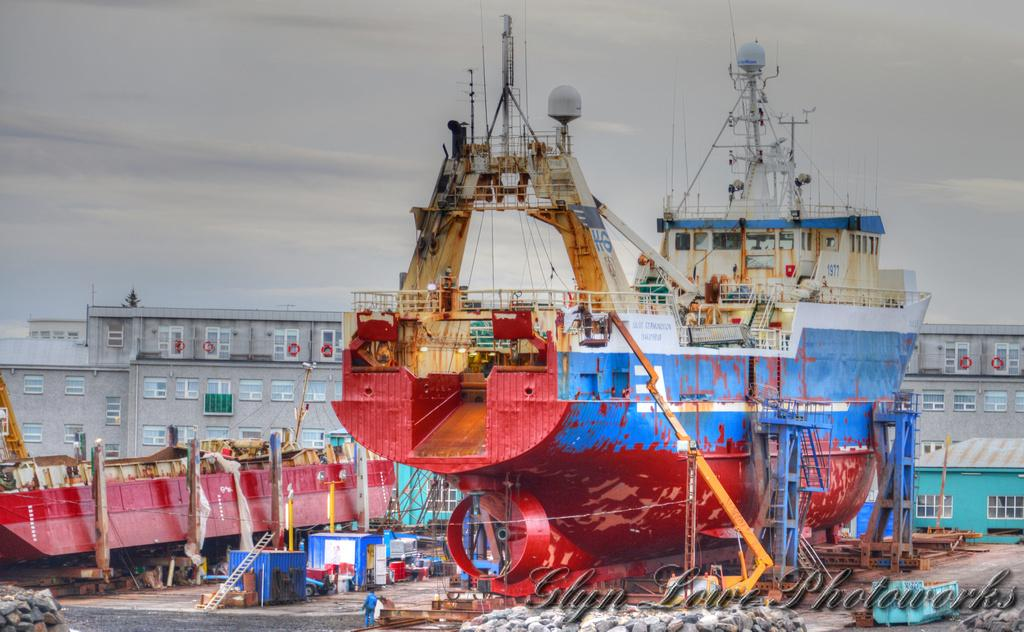What types of structures can be seen in the foreground of the image? There are buildings in the foreground of the image. What is another large object visible in the foreground? There is a ship in the foreground of the image. What natural elements are present in the foreground? There are rocks in the foreground of the image. Are there any living beings in the foreground? Yes, there are people in the foreground of the image. What man-made objects can be seen in the foreground? There is machinery in the foreground of the image. What type of pathway is visible in the foreground? There is a road in the foreground of the image. What else can be found in the foreground of the image? There are various objects in the foreground of the image. What can be seen in the sky at the top of the image? The sky is visible at the top of the image. Can you see the eye of the dog in the image? There is no dog or eye present in the image. What type of flesh can be seen on the machinery in the image? There is no flesh visible in the image; it features buildings, a ship, rocks, people, machinery, a road, and various objects in the foreground, as well as the sky at the top. 